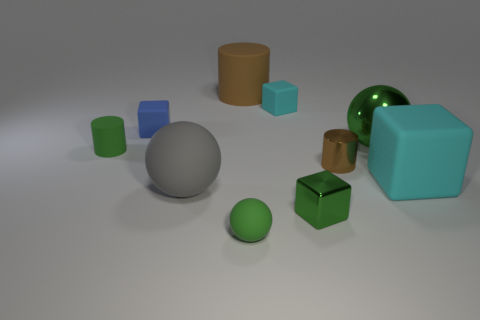Subtract 1 blocks. How many blocks are left? 3 Subtract all blocks. How many objects are left? 6 Add 2 gray metallic things. How many gray metallic things exist? 2 Subtract 0 cyan cylinders. How many objects are left? 10 Subtract all blue objects. Subtract all green metal blocks. How many objects are left? 8 Add 3 large green spheres. How many large green spheres are left? 4 